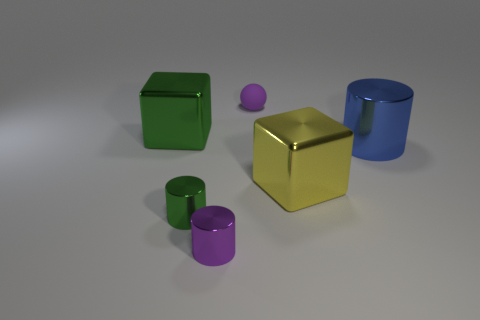Is there anything else that has the same material as the tiny ball?
Your response must be concise. No. What is the shape of the object that is the same color as the small ball?
Keep it short and to the point. Cylinder. Are the purple sphere and the big blue object made of the same material?
Offer a very short reply. No. There is a small cylinder that is the same color as the matte object; what material is it?
Provide a succinct answer. Metal. How many other objects are there of the same color as the sphere?
Provide a succinct answer. 1. Is the number of small brown matte balls less than the number of big shiny cylinders?
Keep it short and to the point. Yes. There is a green metallic thing that is behind the big yellow metal cube behind the tiny purple cylinder; what shape is it?
Keep it short and to the point. Cube. Are there any yellow metallic objects on the right side of the big yellow thing?
Offer a terse response. No. There is another metallic cube that is the same size as the green metallic cube; what is its color?
Offer a very short reply. Yellow. What number of tiny objects have the same material as the big blue thing?
Give a very brief answer. 2. 